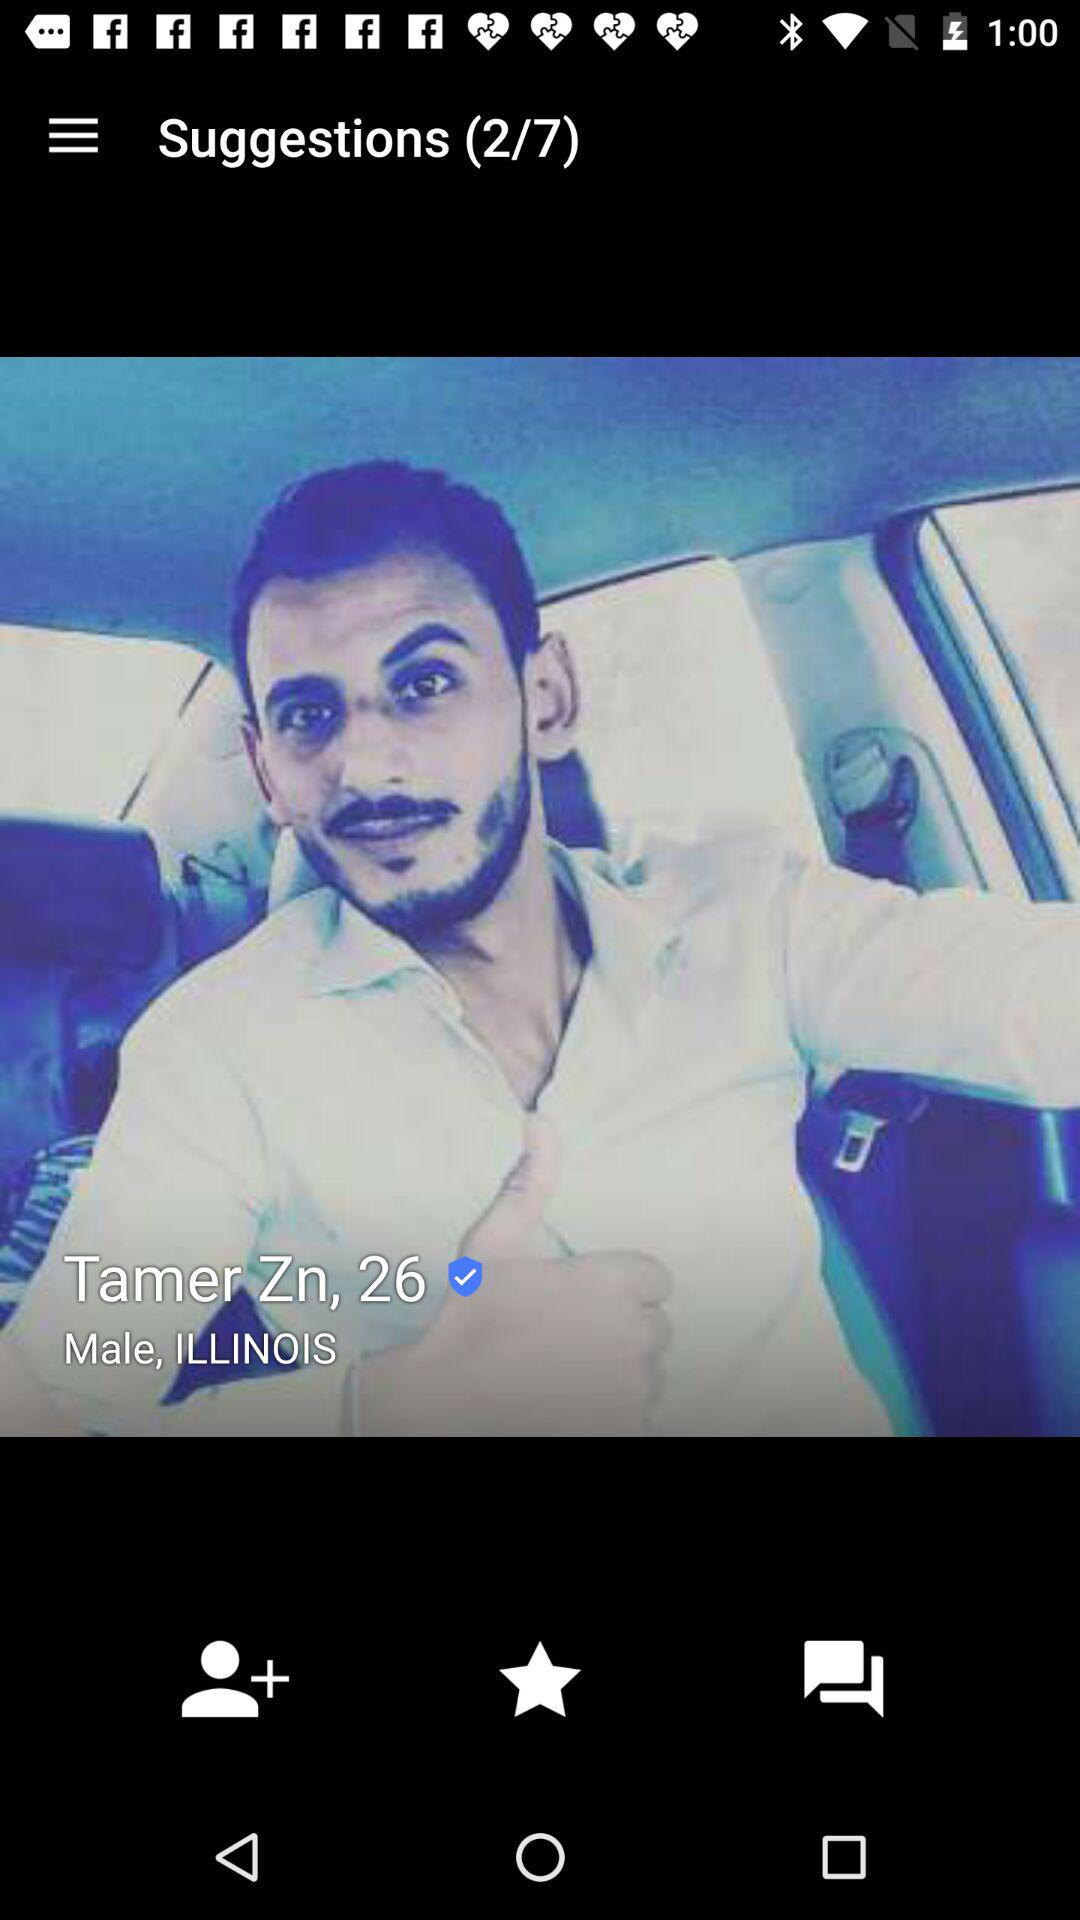How many total suggestions are given? The total suggestions are 7. 